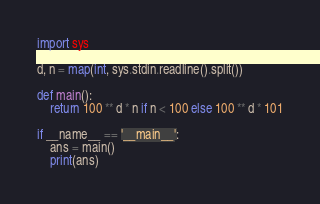Convert code to text. <code><loc_0><loc_0><loc_500><loc_500><_Python_>import sys

d, n = map(int, sys.stdin.readline().split())

def main():
    return 100 ** d * n if n < 100 else 100 ** d * 101

if __name__ == '__main__':
    ans = main()
    print(ans)</code> 